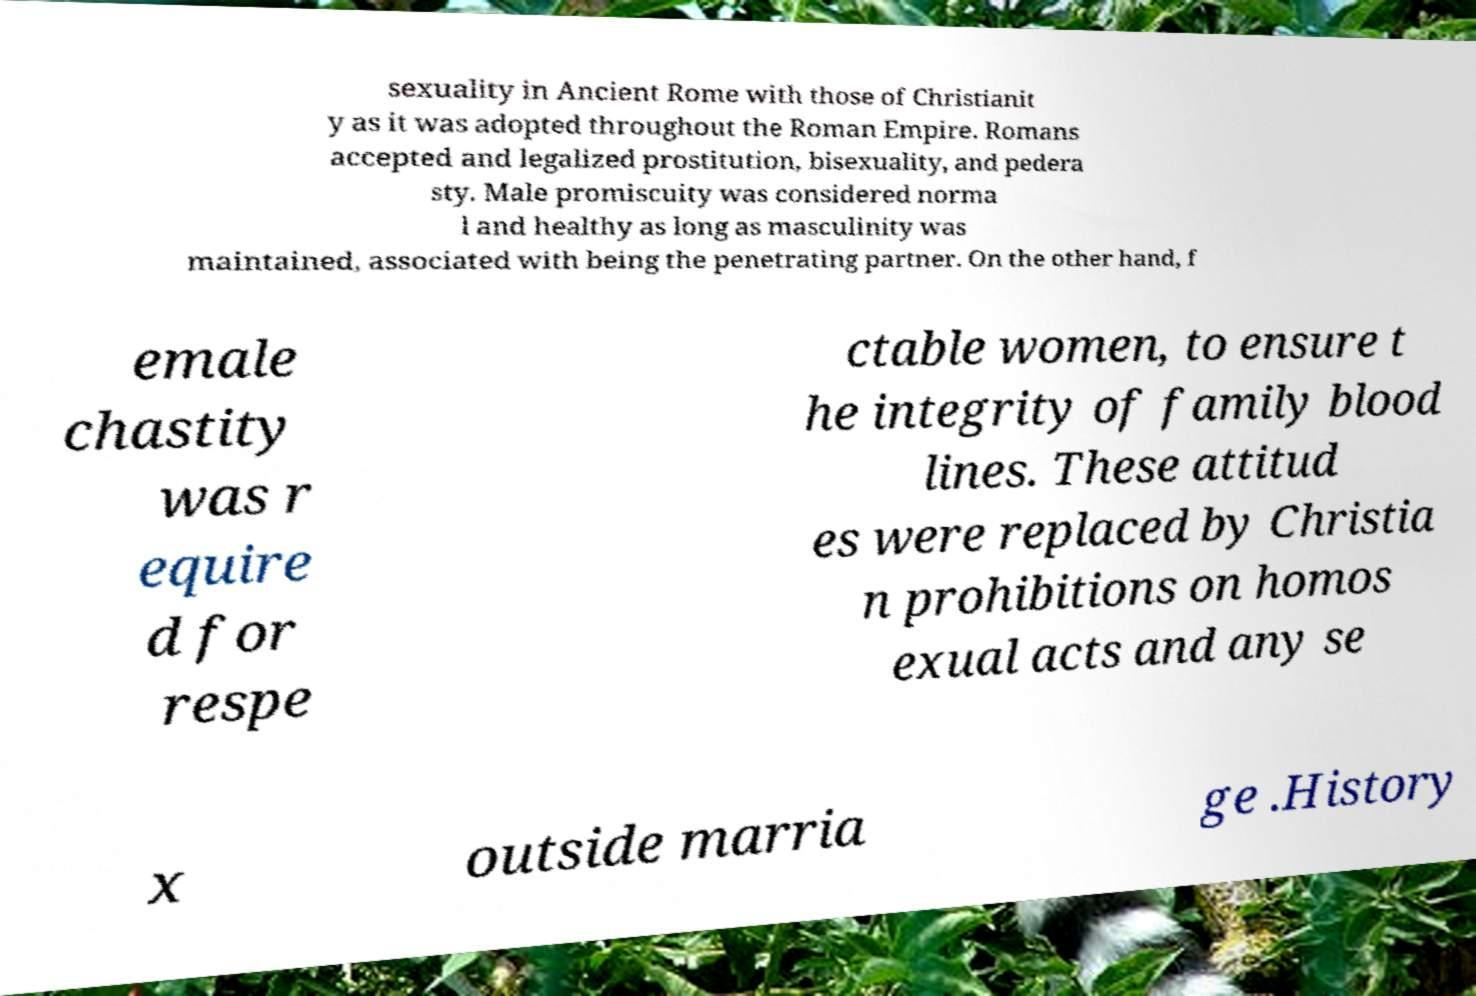What messages or text are displayed in this image? I need them in a readable, typed format. sexuality in Ancient Rome with those of Christianit y as it was adopted throughout the Roman Empire. Romans accepted and legalized prostitution, bisexuality, and pedera sty. Male promiscuity was considered norma l and healthy as long as masculinity was maintained, associated with being the penetrating partner. On the other hand, f emale chastity was r equire d for respe ctable women, to ensure t he integrity of family blood lines. These attitud es were replaced by Christia n prohibitions on homos exual acts and any se x outside marria ge .History 